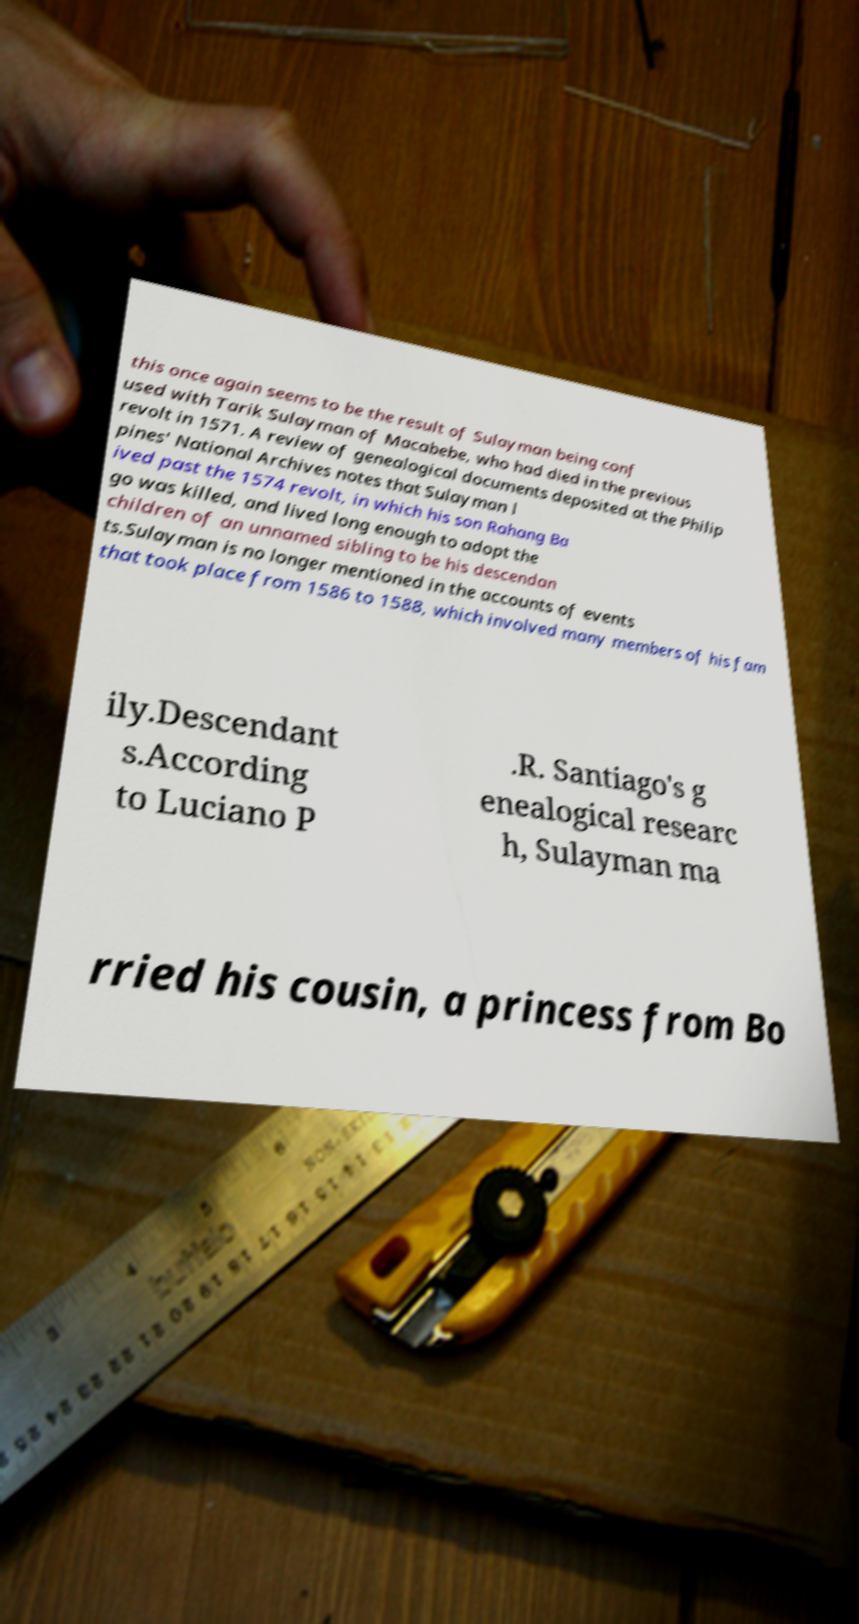Can you read and provide the text displayed in the image?This photo seems to have some interesting text. Can you extract and type it out for me? this once again seems to be the result of Sulayman being conf used with Tarik Sulayman of Macabebe, who had died in the previous revolt in 1571. A review of genealogical documents deposited at the Philip pines' National Archives notes that Sulayman l ived past the 1574 revolt, in which his son Rahang Ba go was killed, and lived long enough to adopt the children of an unnamed sibling to be his descendan ts.Sulayman is no longer mentioned in the accounts of events that took place from 1586 to 1588, which involved many members of his fam ily.Descendant s.According to Luciano P .R. Santiago's g enealogical researc h, Sulayman ma rried his cousin, a princess from Bo 